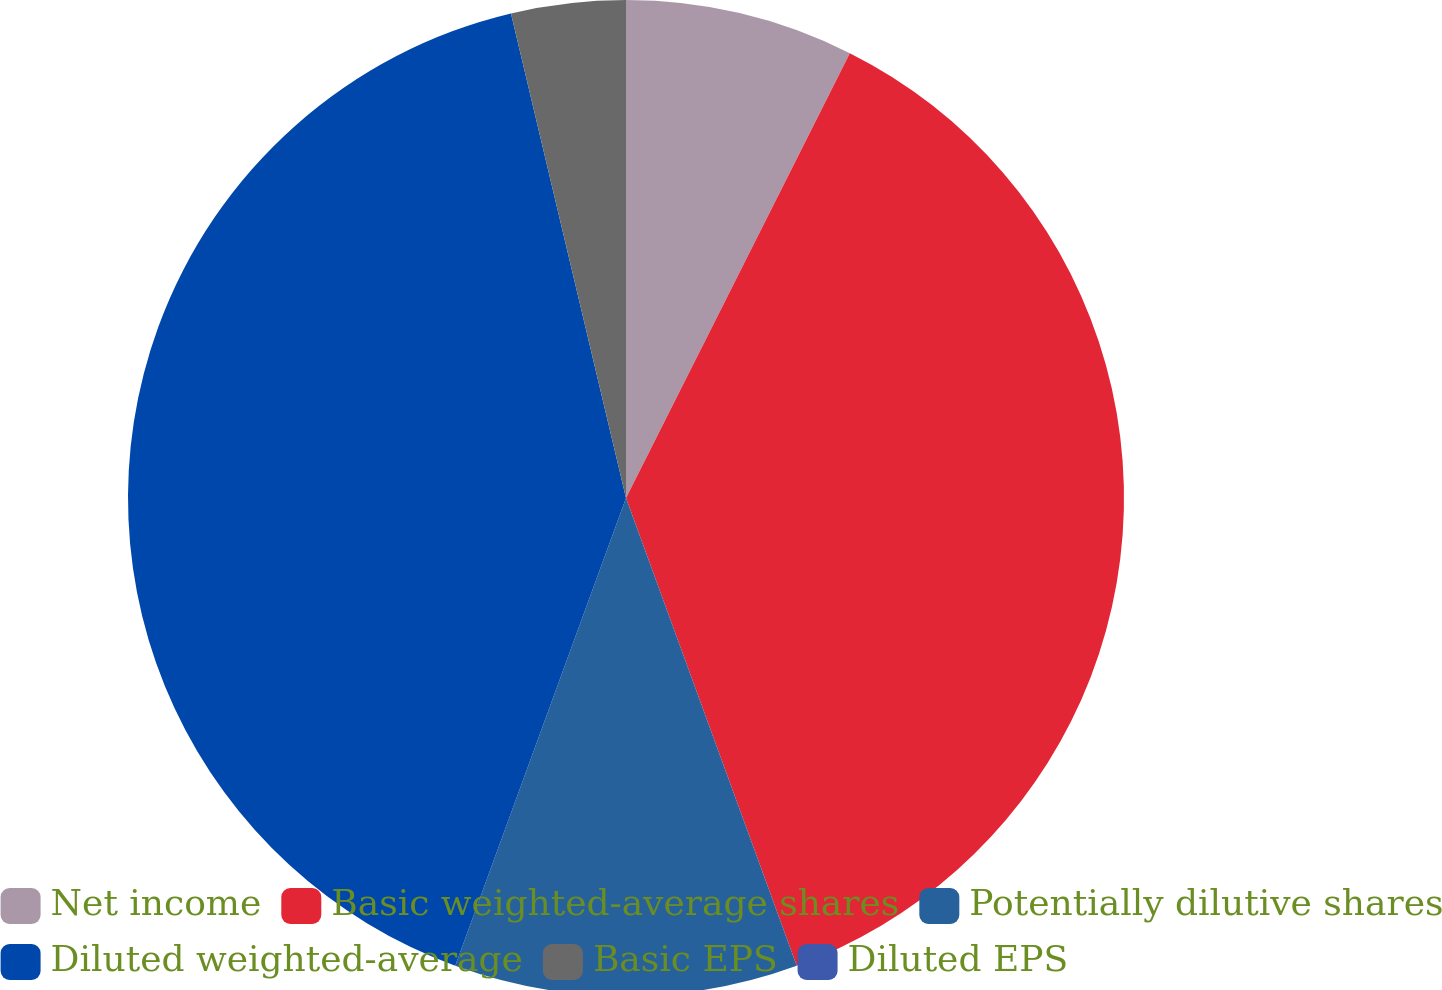<chart> <loc_0><loc_0><loc_500><loc_500><pie_chart><fcel>Net income<fcel>Basic weighted-average shares<fcel>Potentially dilutive shares<fcel>Diluted weighted-average<fcel>Basic EPS<fcel>Diluted EPS<nl><fcel>7.42%<fcel>37.01%<fcel>11.14%<fcel>40.72%<fcel>3.71%<fcel>0.0%<nl></chart> 